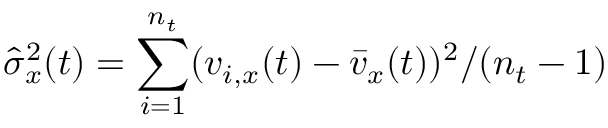<formula> <loc_0><loc_0><loc_500><loc_500>\hat { \sigma } _ { x } ^ { 2 } ( t ) = \sum _ { i = 1 } ^ { n _ { t } } ( v _ { i , x } ( t ) - \bar { v } _ { x } ( t ) ) ^ { 2 } / ( n _ { t } - 1 )</formula> 